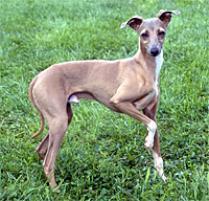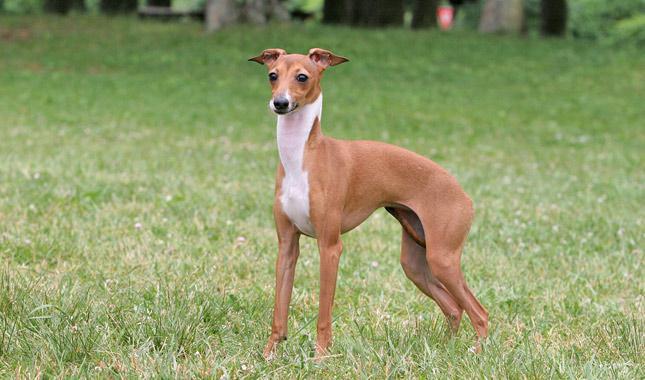The first image is the image on the left, the second image is the image on the right. Given the left and right images, does the statement "There is at least one dog laying down." hold true? Answer yes or no. No. The first image is the image on the left, the second image is the image on the right. Examine the images to the left and right. Is the description "A dog is curled up next to some type of cushion." accurate? Answer yes or no. No. 